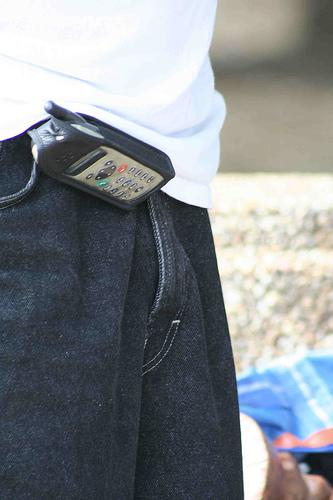Question: how is the phone hanging?
Choices:
A. Upside down.
B. Sideways.
C. Straight.
D. Crookedly.
Answer with the letter. Answer: B Question: why is there a green button on the phone?
Choices:
A. To make calls.
B. To hear.
C. Call button.
D. To make it look nice.
Answer with the letter. Answer: C Question: how is the phone attached to his waist?
Choices:
A. Belt.
B. A phone case.
C. String.
D. Rope.
Answer with the letter. Answer: B 